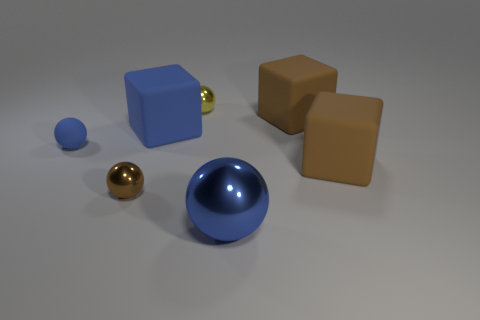Subtract 1 spheres. How many spheres are left? 3 Add 2 large brown shiny balls. How many objects exist? 9 Subtract all blocks. How many objects are left? 4 Subtract 0 gray cylinders. How many objects are left? 7 Subtract all green rubber things. Subtract all blue matte blocks. How many objects are left? 6 Add 3 tiny shiny balls. How many tiny shiny balls are left? 5 Add 5 tiny blue things. How many tiny blue things exist? 6 